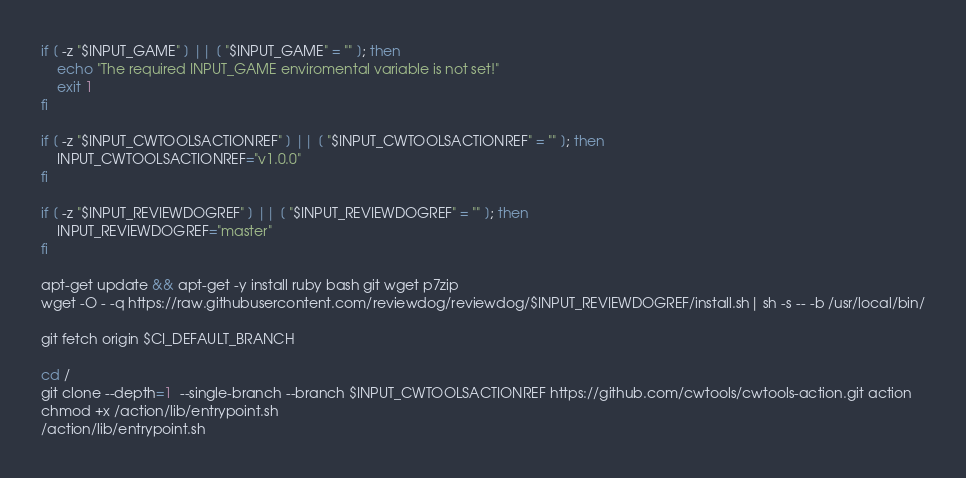Convert code to text. <code><loc_0><loc_0><loc_500><loc_500><_Bash_>if [ -z "$INPUT_GAME" ] || [ "$INPUT_GAME" = "" ]; then
    echo "The required INPUT_GAME enviromental variable is not set!"
    exit 1
fi

if [ -z "$INPUT_CWTOOLSACTIONREF" ] || [ "$INPUT_CWTOOLSACTIONREF" = "" ]; then
    INPUT_CWTOOLSACTIONREF="v1.0.0"
fi

if [ -z "$INPUT_REVIEWDOGREF" ] || [ "$INPUT_REVIEWDOGREF" = "" ]; then
    INPUT_REVIEWDOGREF="master"
fi

apt-get update && apt-get -y install ruby bash git wget p7zip
wget -O - -q https://raw.githubusercontent.com/reviewdog/reviewdog/$INPUT_REVIEWDOGREF/install.sh| sh -s -- -b /usr/local/bin/

git fetch origin $CI_DEFAULT_BRANCH

cd /
git clone --depth=1  --single-branch --branch $INPUT_CWTOOLSACTIONREF https://github.com/cwtools/cwtools-action.git action
chmod +x /action/lib/entrypoint.sh
/action/lib/entrypoint.sh
</code> 